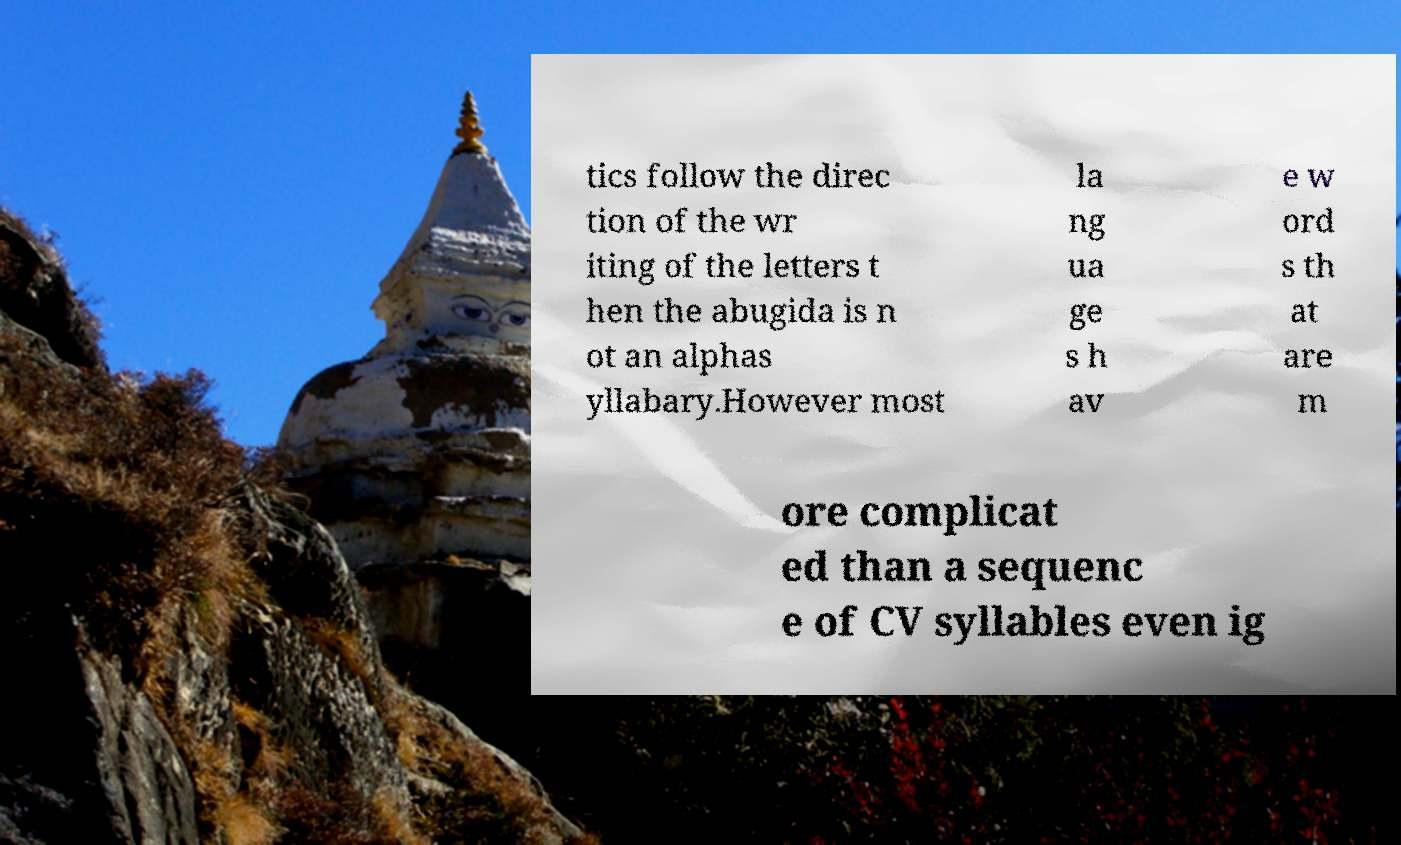Can you read and provide the text displayed in the image?This photo seems to have some interesting text. Can you extract and type it out for me? tics follow the direc tion of the wr iting of the letters t hen the abugida is n ot an alphas yllabary.However most la ng ua ge s h av e w ord s th at are m ore complicat ed than a sequenc e of CV syllables even ig 